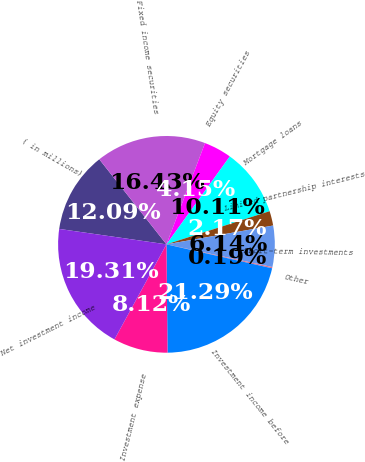Convert chart to OTSL. <chart><loc_0><loc_0><loc_500><loc_500><pie_chart><fcel>( in millions)<fcel>Fixed income securities<fcel>Equity securities<fcel>Mortgage loans<fcel>Limited partnership interests<fcel>Short-term investments<fcel>Other<fcel>Investment income before<fcel>Investment expense<fcel>Net investment income<nl><fcel>12.09%<fcel>16.43%<fcel>4.15%<fcel>10.11%<fcel>2.17%<fcel>6.14%<fcel>0.19%<fcel>21.29%<fcel>8.12%<fcel>19.31%<nl></chart> 